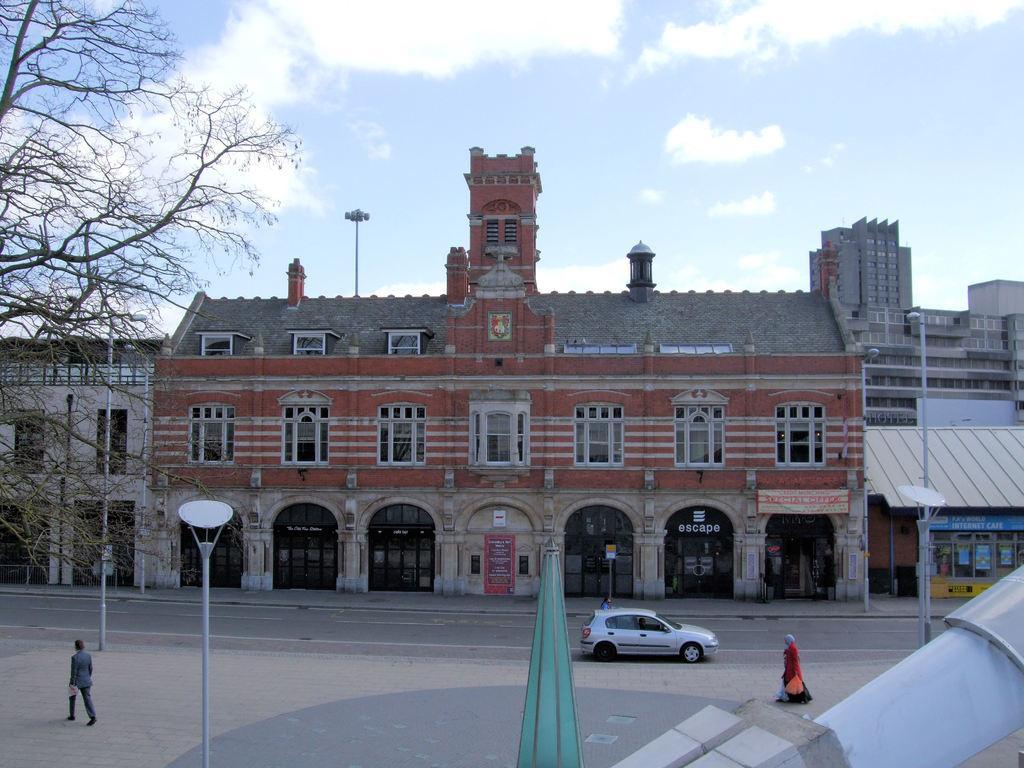Describe this image in one or two sentences. In this image there is the sky truncated towards the top of the image, there are clouds in the sky, there are buildings, there is a building truncated towards the right of the image, there is a building truncated towards the left of the image, there are windows, there is a tree truncated towards the left of the image, there are poles, there are poles truncated towards the bottom of the image, there are objects truncated towards the bottom of the image, there are two persons walking, there are holding an object, there is a car on the road, there is a board, there is text on the board. 